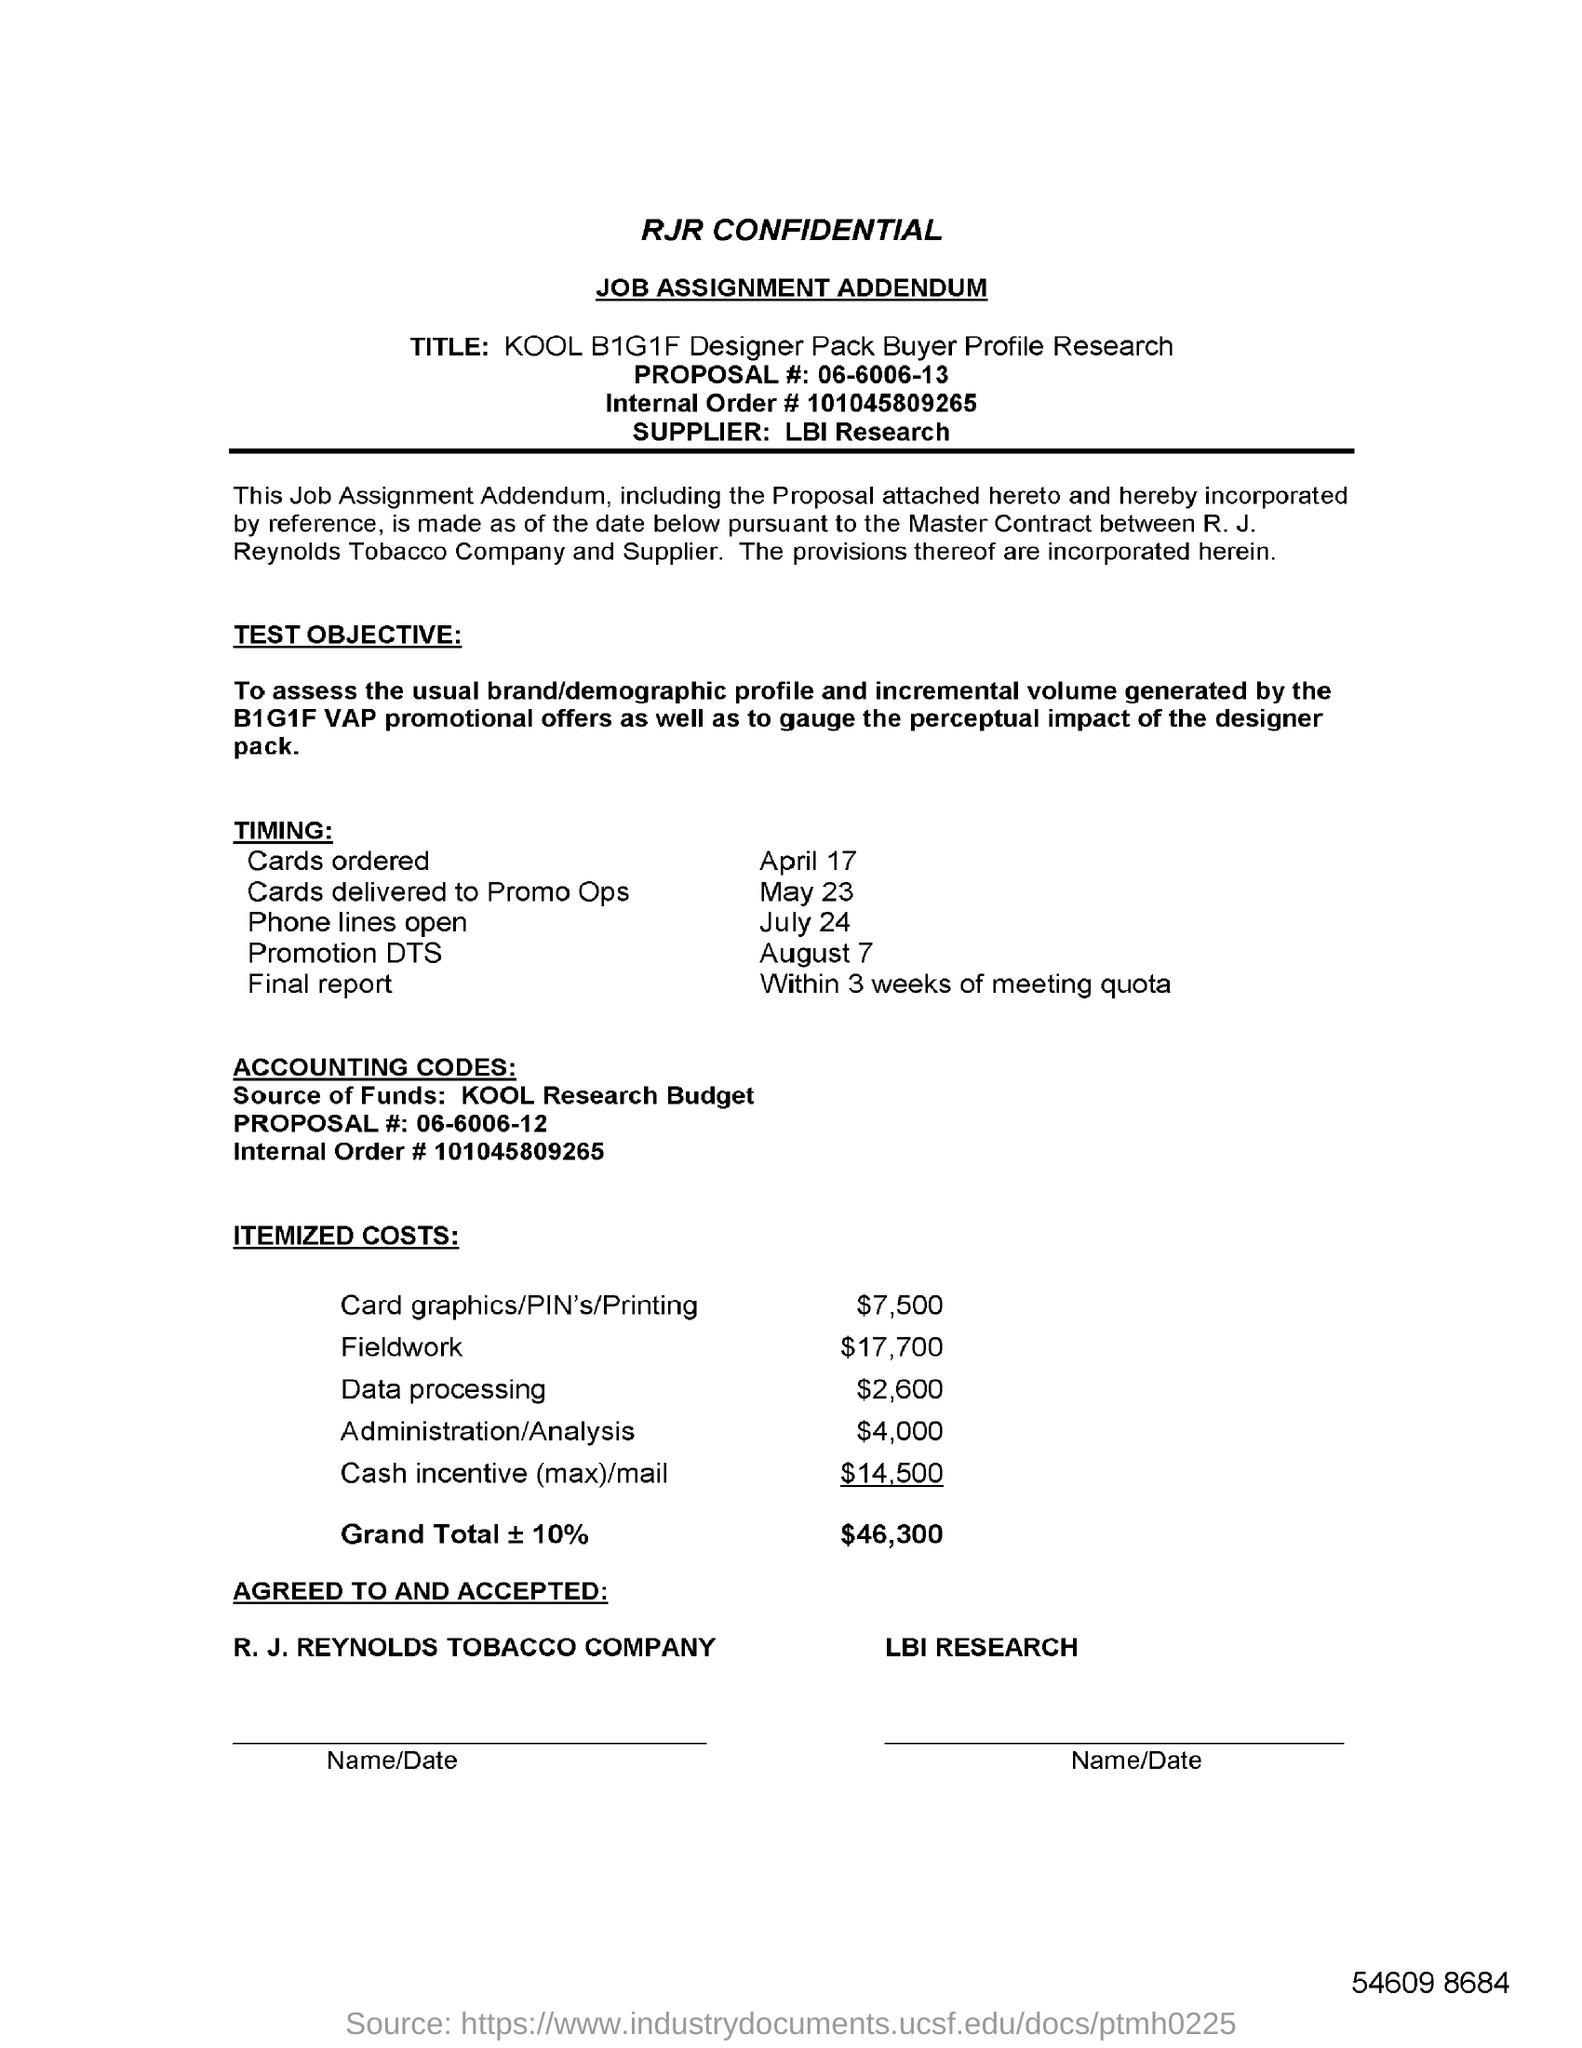Highlight a few significant elements in this photo. The internal order number is 101045809265. The itemized costs for field work total $17,700. The timing for phone lines to open is July 24. The proposal number is 06-6006-13. The itemized costs for data processing are 2,600. 